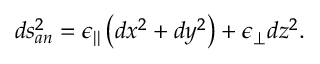Convert formula to latex. <formula><loc_0><loc_0><loc_500><loc_500>d s _ { a n } ^ { 2 } = \epsilon _ { | | } \left ( d x ^ { 2 } + d y ^ { 2 } \right ) + \epsilon _ { \perp } d z ^ { 2 } .</formula> 